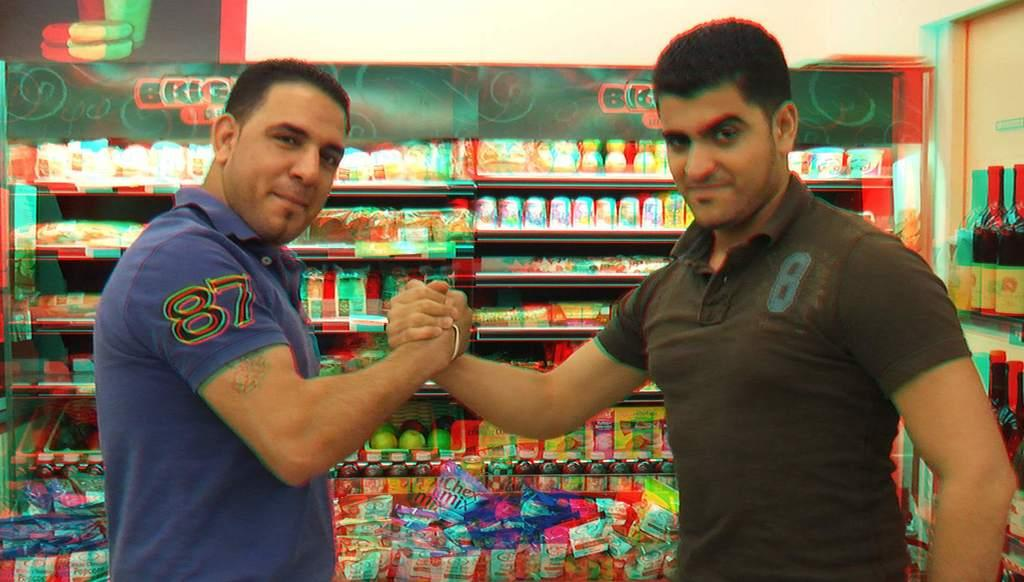<image>
Describe the image concisely. A man wearing the number 87 shakes hands with a man wearing the number 8. 